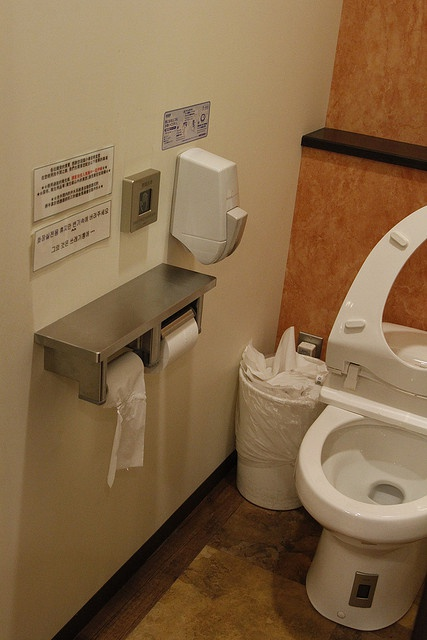Describe the objects in this image and their specific colors. I can see a toilet in tan, gray, and maroon tones in this image. 